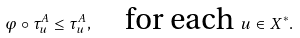<formula> <loc_0><loc_0><loc_500><loc_500>\varphi \circ \tau _ { u } ^ { A } \leq \tau _ { u } ^ { A } , \quad \text {for each} \ u \in X ^ { * } .</formula> 